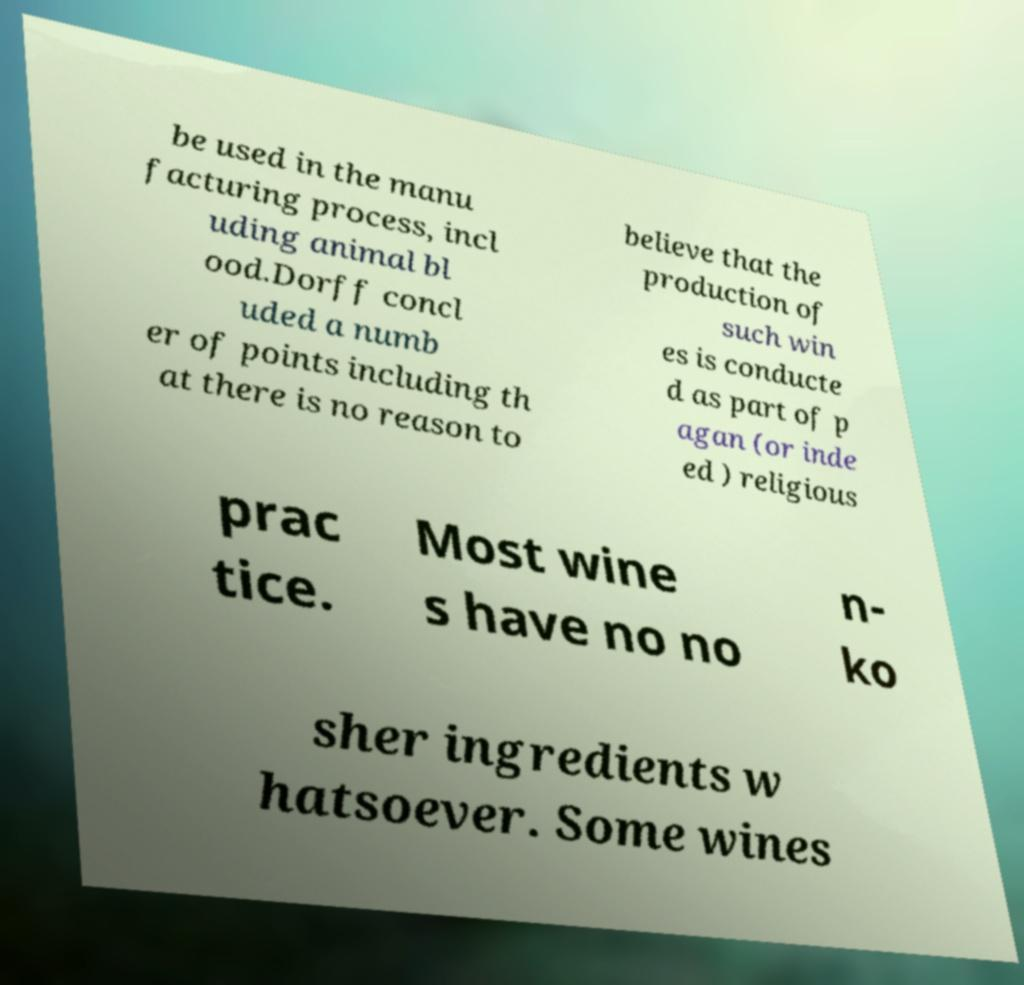I need the written content from this picture converted into text. Can you do that? be used in the manu facturing process, incl uding animal bl ood.Dorff concl uded a numb er of points including th at there is no reason to believe that the production of such win es is conducte d as part of p agan (or inde ed ) religious prac tice. Most wine s have no no n- ko sher ingredients w hatsoever. Some wines 